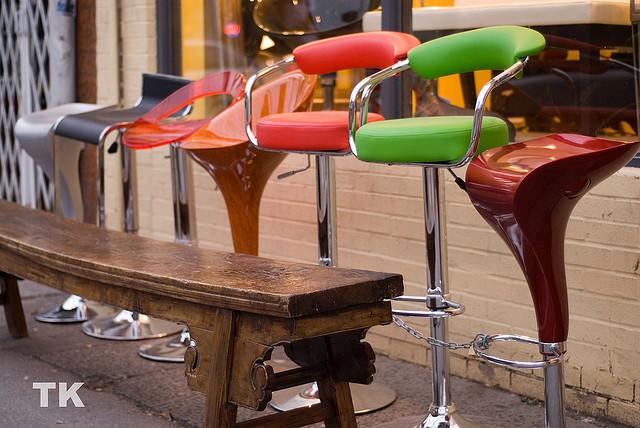What is the brown structure likely made of?

Choices:
A) cotton
B) wood
C) brick
D) metal wood 